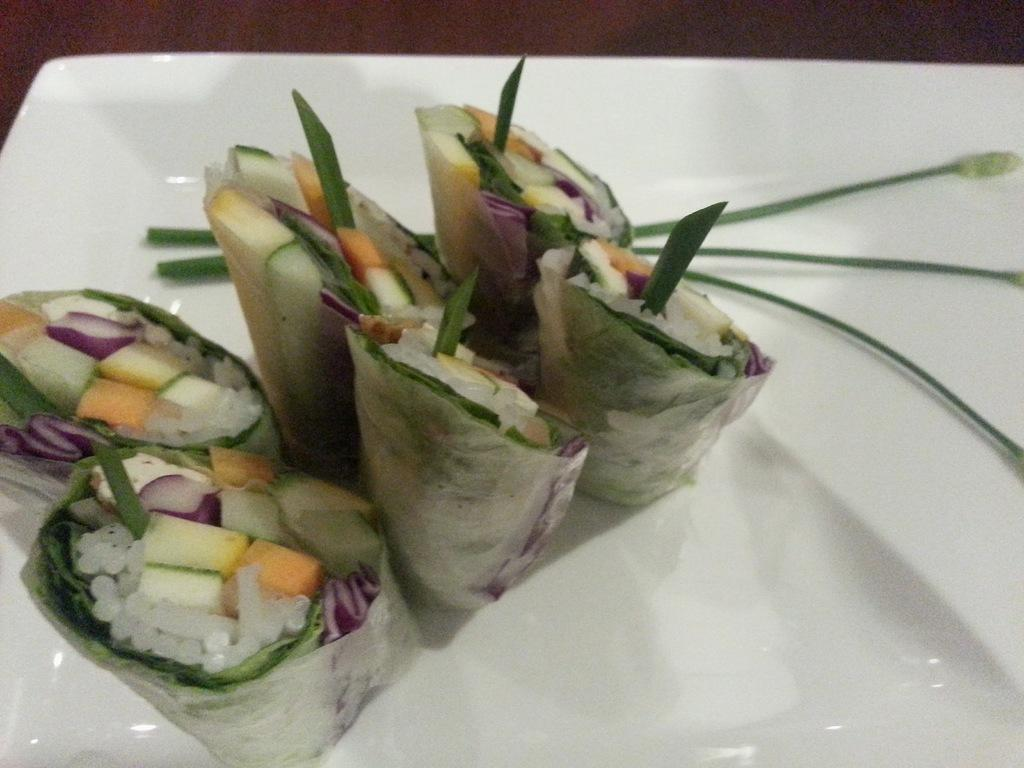What is present in the image? There is food in the image. Can you describe the plate in the image? There is a white plate at the bottom of the image. What type of wood is used to make the table in the image? There is no table present in the image, so it is not possible to determine the type of wood used. 